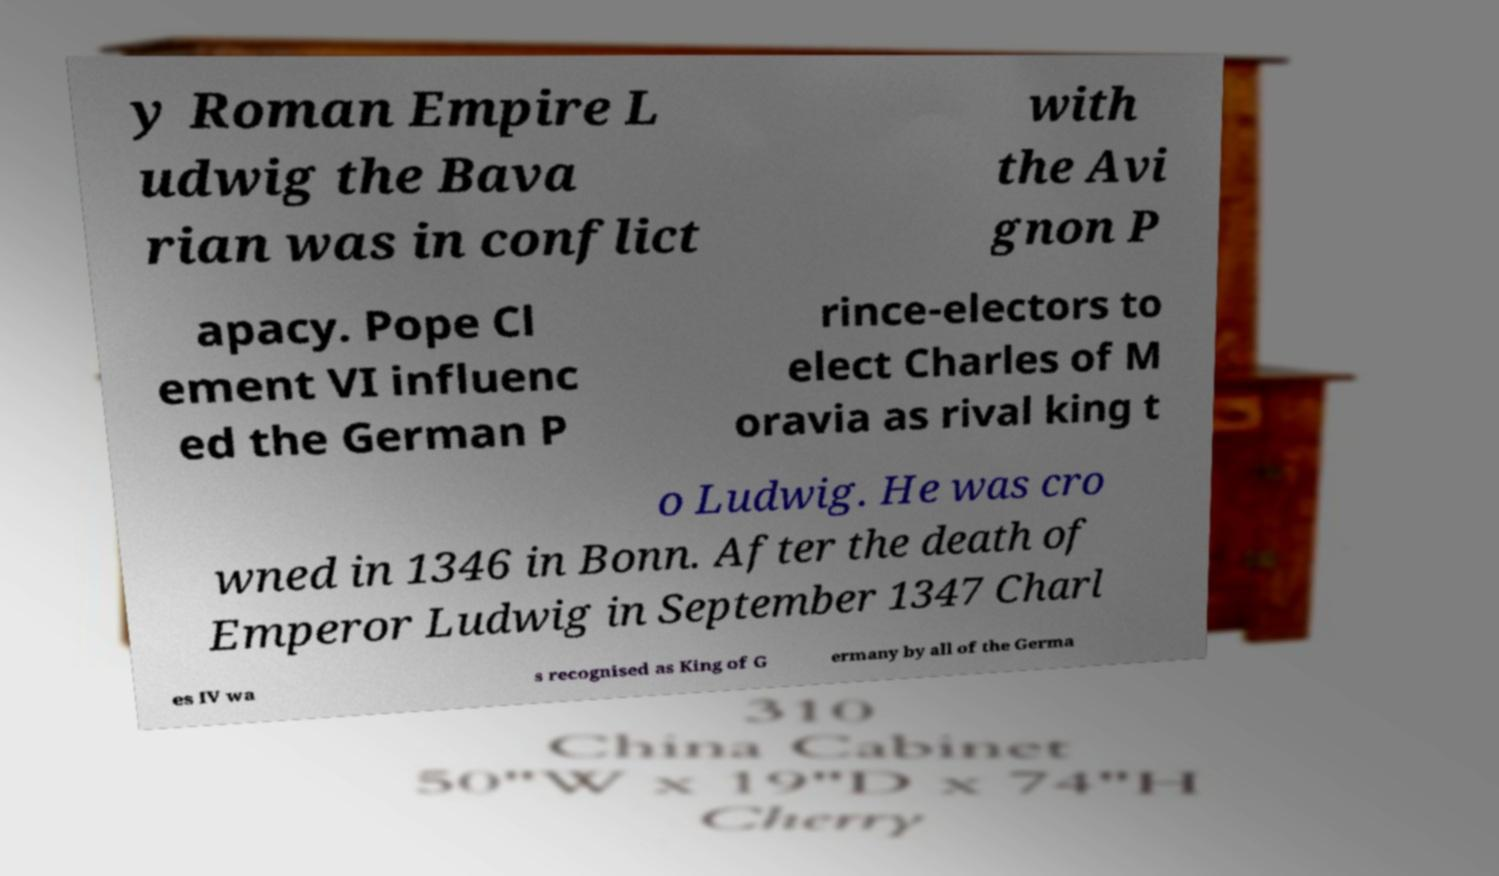There's text embedded in this image that I need extracted. Can you transcribe it verbatim? y Roman Empire L udwig the Bava rian was in conflict with the Avi gnon P apacy. Pope Cl ement VI influenc ed the German P rince-electors to elect Charles of M oravia as rival king t o Ludwig. He was cro wned in 1346 in Bonn. After the death of Emperor Ludwig in September 1347 Charl es IV wa s recognised as King of G ermany by all of the Germa 